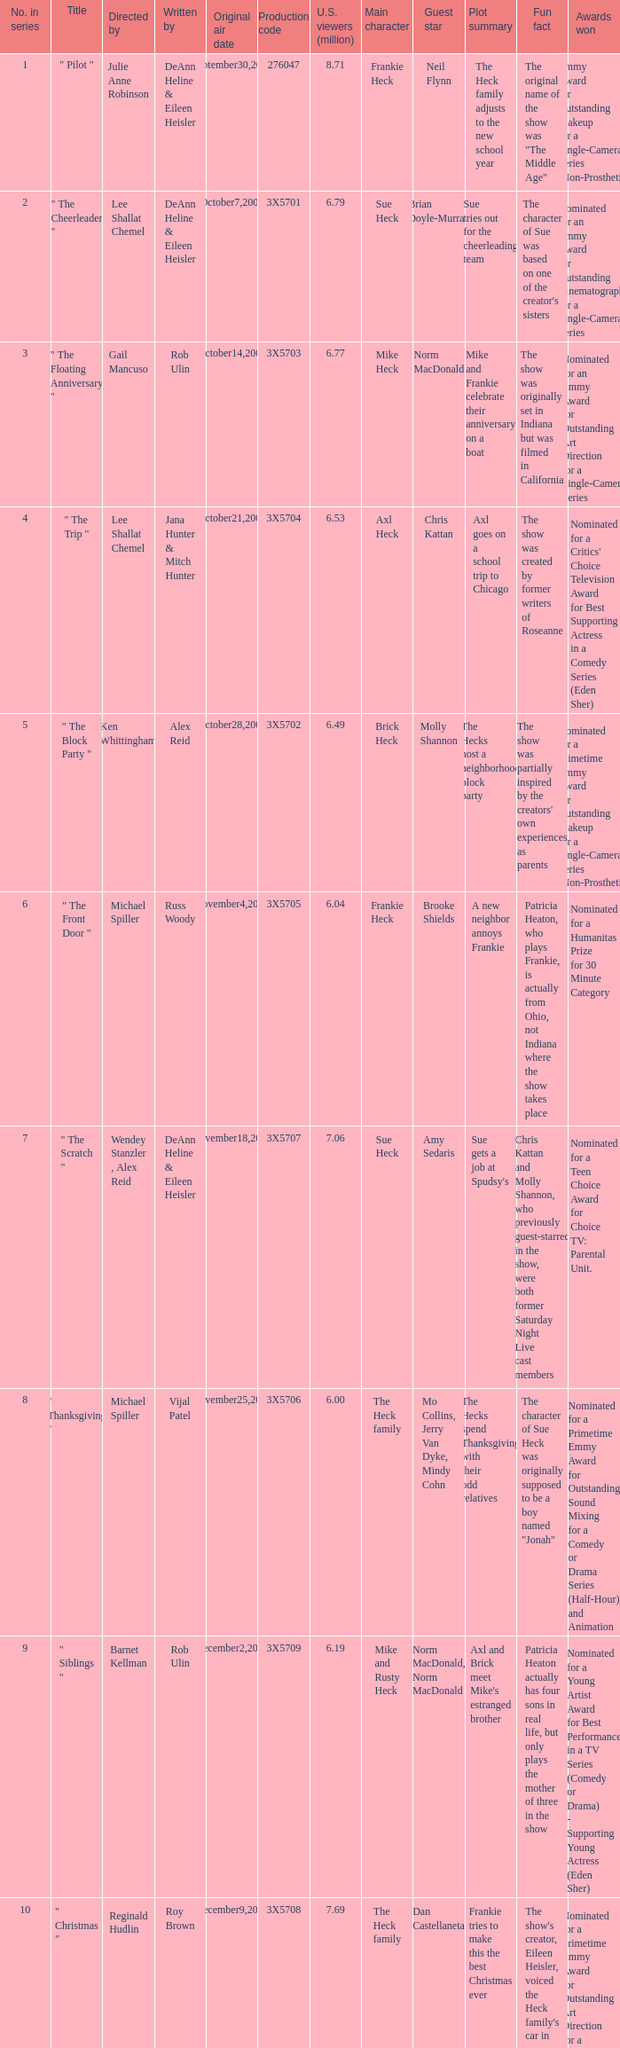What is the title of the episode Alex Reid directed? "The Final Four". 